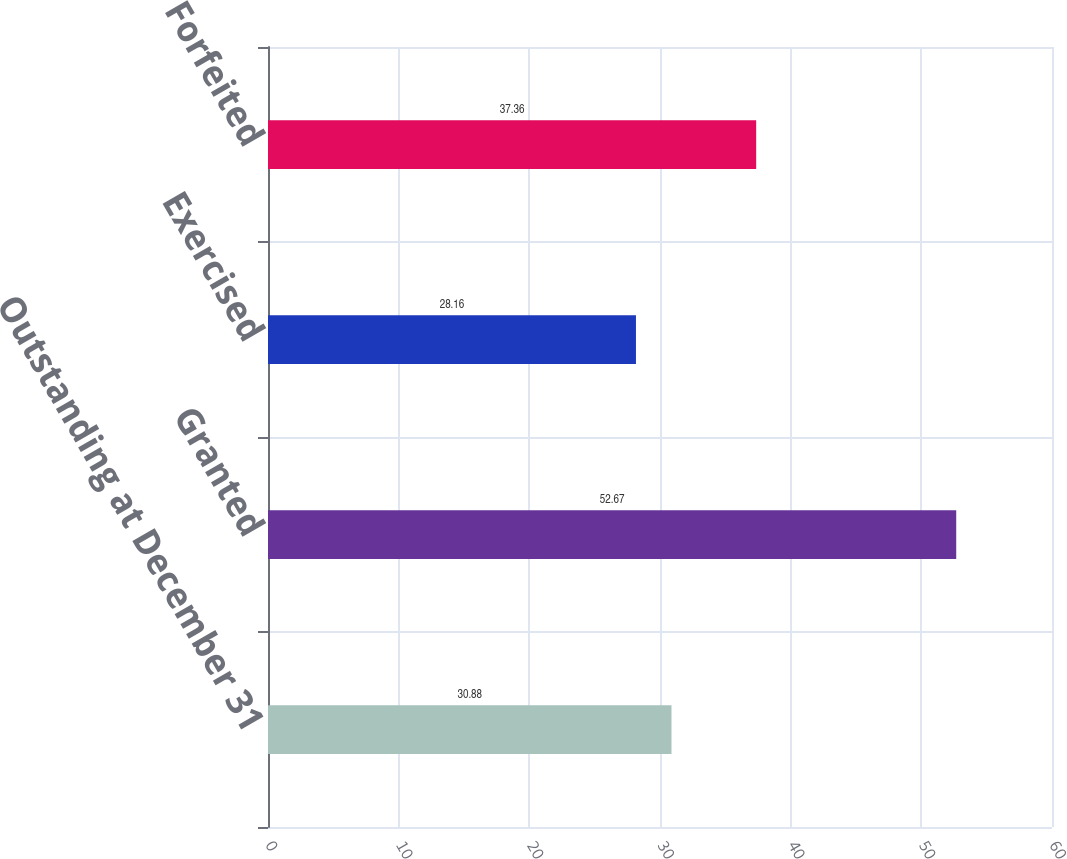<chart> <loc_0><loc_0><loc_500><loc_500><bar_chart><fcel>Outstanding at December 31<fcel>Granted<fcel>Exercised<fcel>Forfeited<nl><fcel>30.88<fcel>52.67<fcel>28.16<fcel>37.36<nl></chart> 